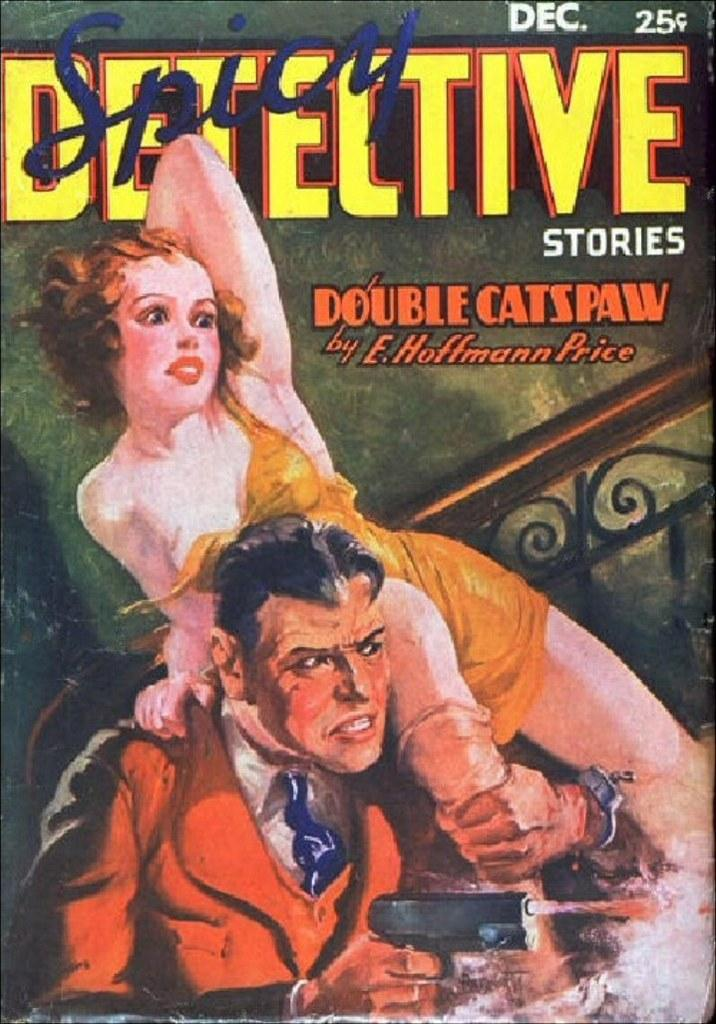<image>
Present a compact description of the photo's key features. A comic book cover for Spicy Detective shows the price as 25 cents. 